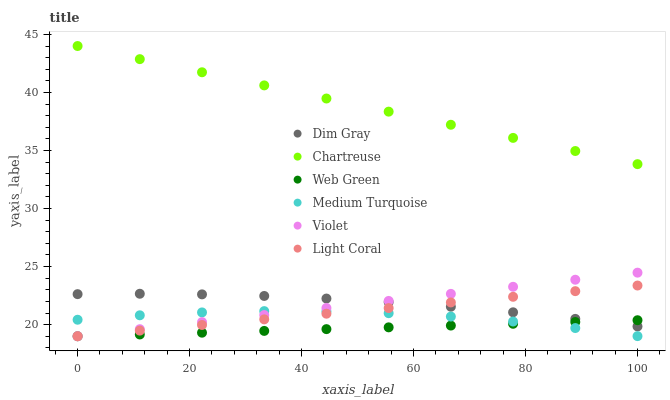Does Web Green have the minimum area under the curve?
Answer yes or no. Yes. Does Chartreuse have the maximum area under the curve?
Answer yes or no. Yes. Does Light Coral have the minimum area under the curve?
Answer yes or no. No. Does Light Coral have the maximum area under the curve?
Answer yes or no. No. Is Light Coral the smoothest?
Answer yes or no. Yes. Is Medium Turquoise the roughest?
Answer yes or no. Yes. Is Web Green the smoothest?
Answer yes or no. No. Is Web Green the roughest?
Answer yes or no. No. Does Web Green have the lowest value?
Answer yes or no. Yes. Does Chartreuse have the lowest value?
Answer yes or no. No. Does Chartreuse have the highest value?
Answer yes or no. Yes. Does Light Coral have the highest value?
Answer yes or no. No. Is Medium Turquoise less than Chartreuse?
Answer yes or no. Yes. Is Chartreuse greater than Dim Gray?
Answer yes or no. Yes. Does Light Coral intersect Web Green?
Answer yes or no. Yes. Is Light Coral less than Web Green?
Answer yes or no. No. Is Light Coral greater than Web Green?
Answer yes or no. No. Does Medium Turquoise intersect Chartreuse?
Answer yes or no. No. 